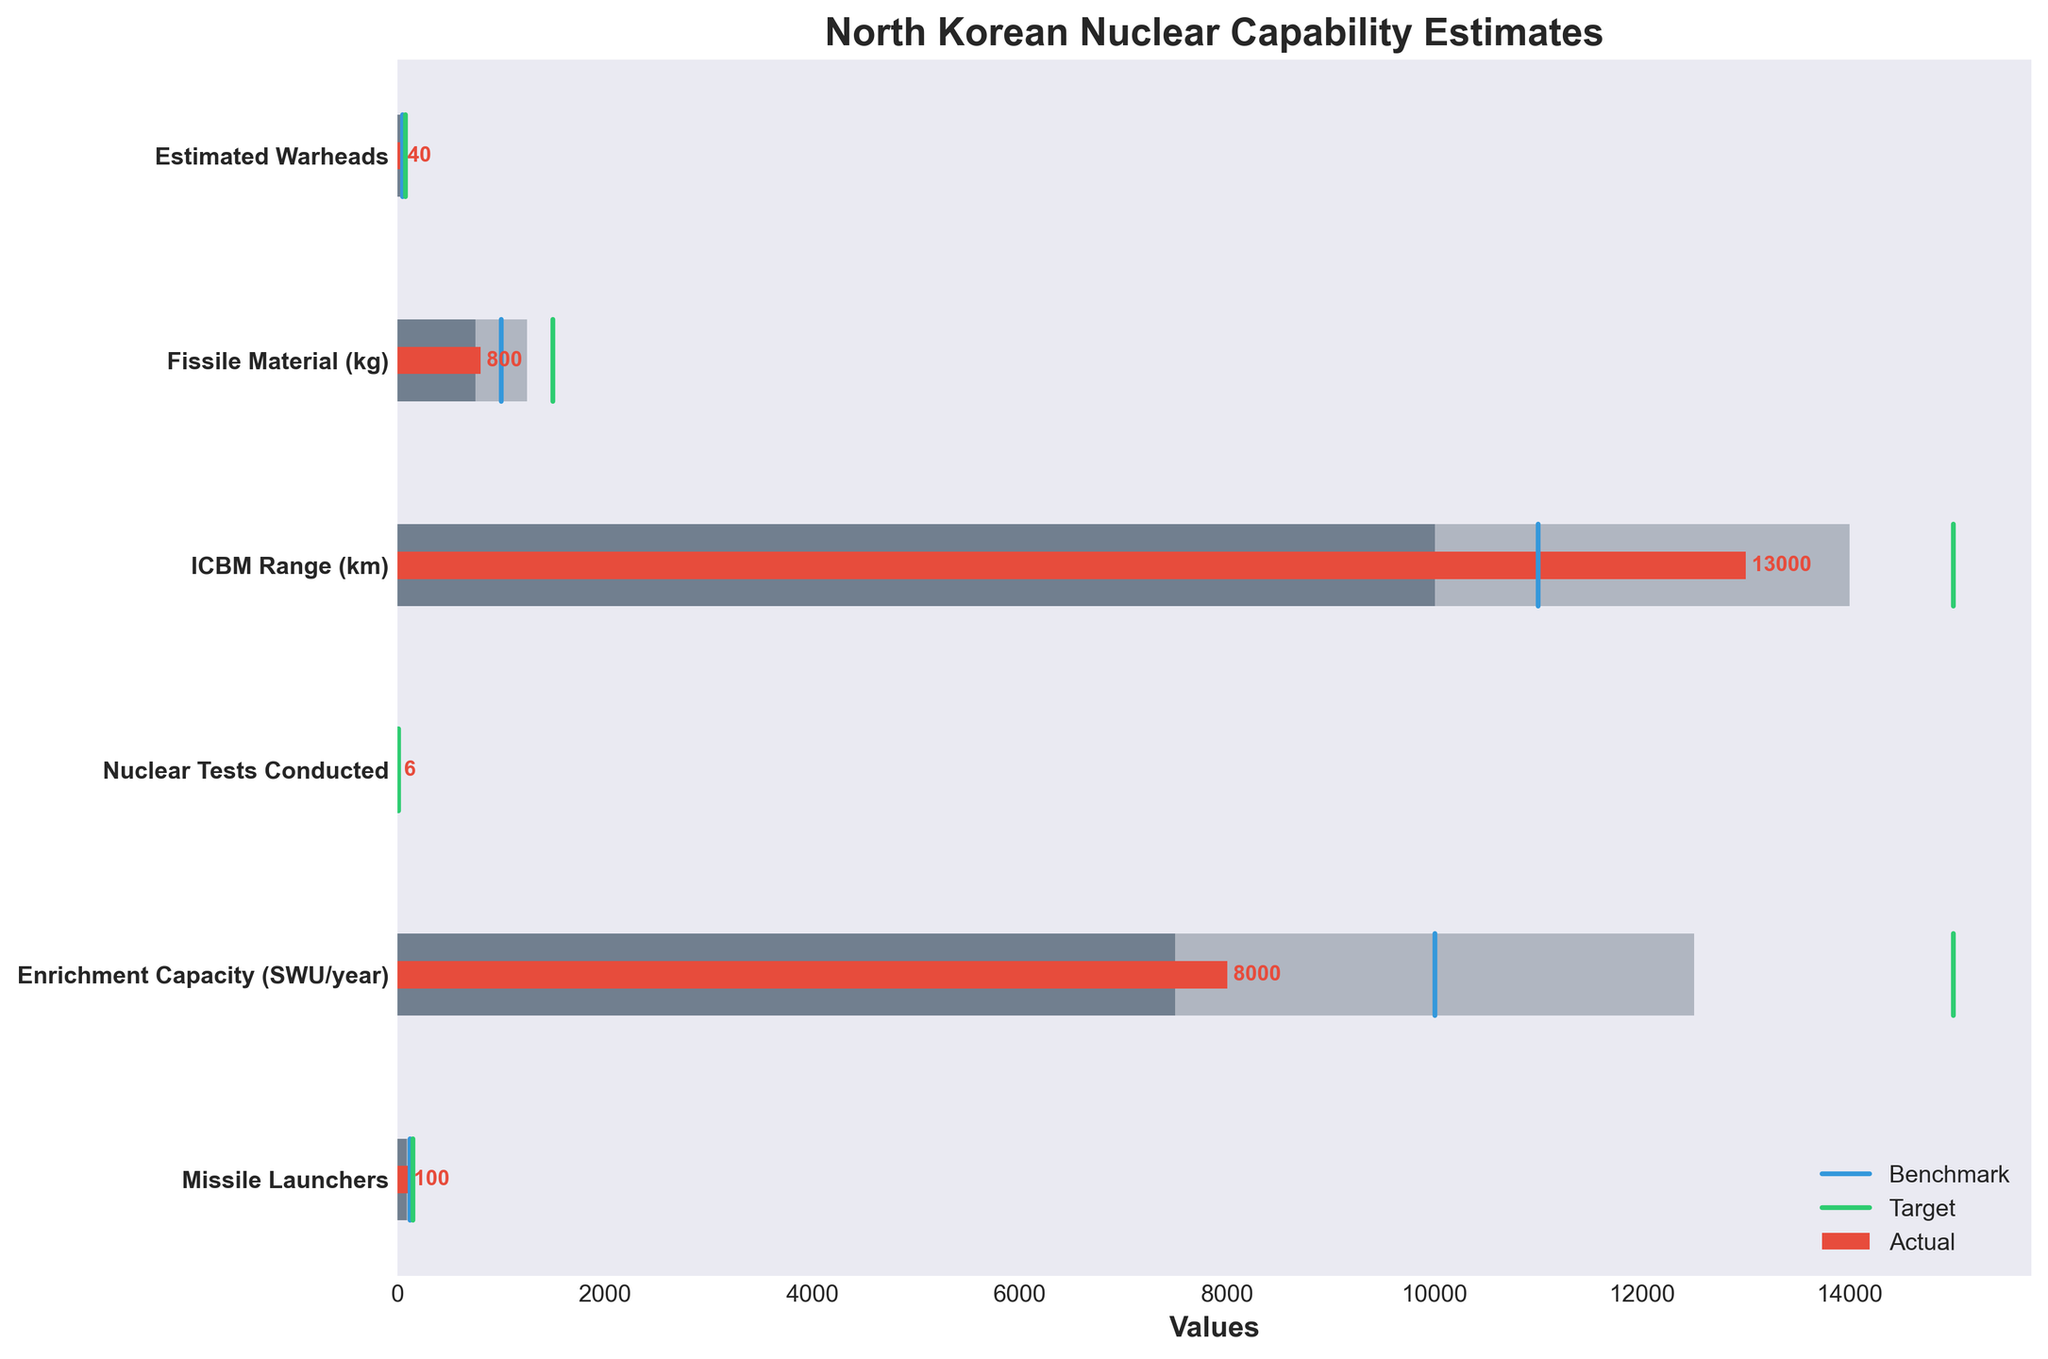What's the category with the highest actual value? To find the category with the highest actual value, look at the red bars representing the actual values and find the maximum value. The category "Missile Launchers" has the highest actual value of 100.
Answer: Missile Launchers What is the difference between the target and the actual value for ICBM Range (km)? For ICBM Range, the target value is 15000 km and the actual value is 13000 km. The difference is 15000 km - 13000 km = 2000 km.
Answer: 2000 km How many categories have an actual value below their benchmark value? Compare the red bars (actual values) with the blue lines (benchmark values). The categories with actual values below their benchmarks are "Estimated Warheads," "Fissile Material (kg)," "ICBM Range (km)," "Nuclear Tests Conducted," "Enrichment Capacity (SWU/year)," and "Missile Launchers." There are 6 categories in total.
Answer: 6 Which category has actual values closest to its target value? Look at the red bars (actual values) and the green lines (target values) and find the smallest difference. The category "Missile Launchers" has an actual value of 100 and a target value of 150, resulting in a difference of 50, which is the smallest among all categories.
Answer: Missile Launchers What range of values represents the medium performance band for Enrichment Capacity (SWU/year)? For Enrichment Capacity, the medium performance band is represented by the second color bar. The range of values for the medium band is from 7500 to 12500 SWU/year.
Answer: 7500-12500 SWU/year How many nuclear tests has North Korea conducted relative to the international benchmark? The actual value for "Nuclear Tests Conducted" is 6, while the benchmark value is 8. North Korea has conducted 2 fewer nuclear tests than the international benchmark.
Answer: 2 fewer What is the average target value across all categories? Sum the target values of all categories and divide by the number of categories. The target values are 75, 1500, 15000, 10, 15000, and 150. Sum = 75 + 1500 + 15000 + 10 + 15000 + 150 = 31735. There are 6 categories, so the average is 31735 / 6 = 5289.17
Answer: 5289.17 Which category has the lowest high-performance benchmark, and what is it? The high-performance benchmarks are the end points of the darkest bars. The category "Enrichment Capacity" has the lowest high-performance benchmark of 12500.
Answer: Enrichment Capacity, 12500 